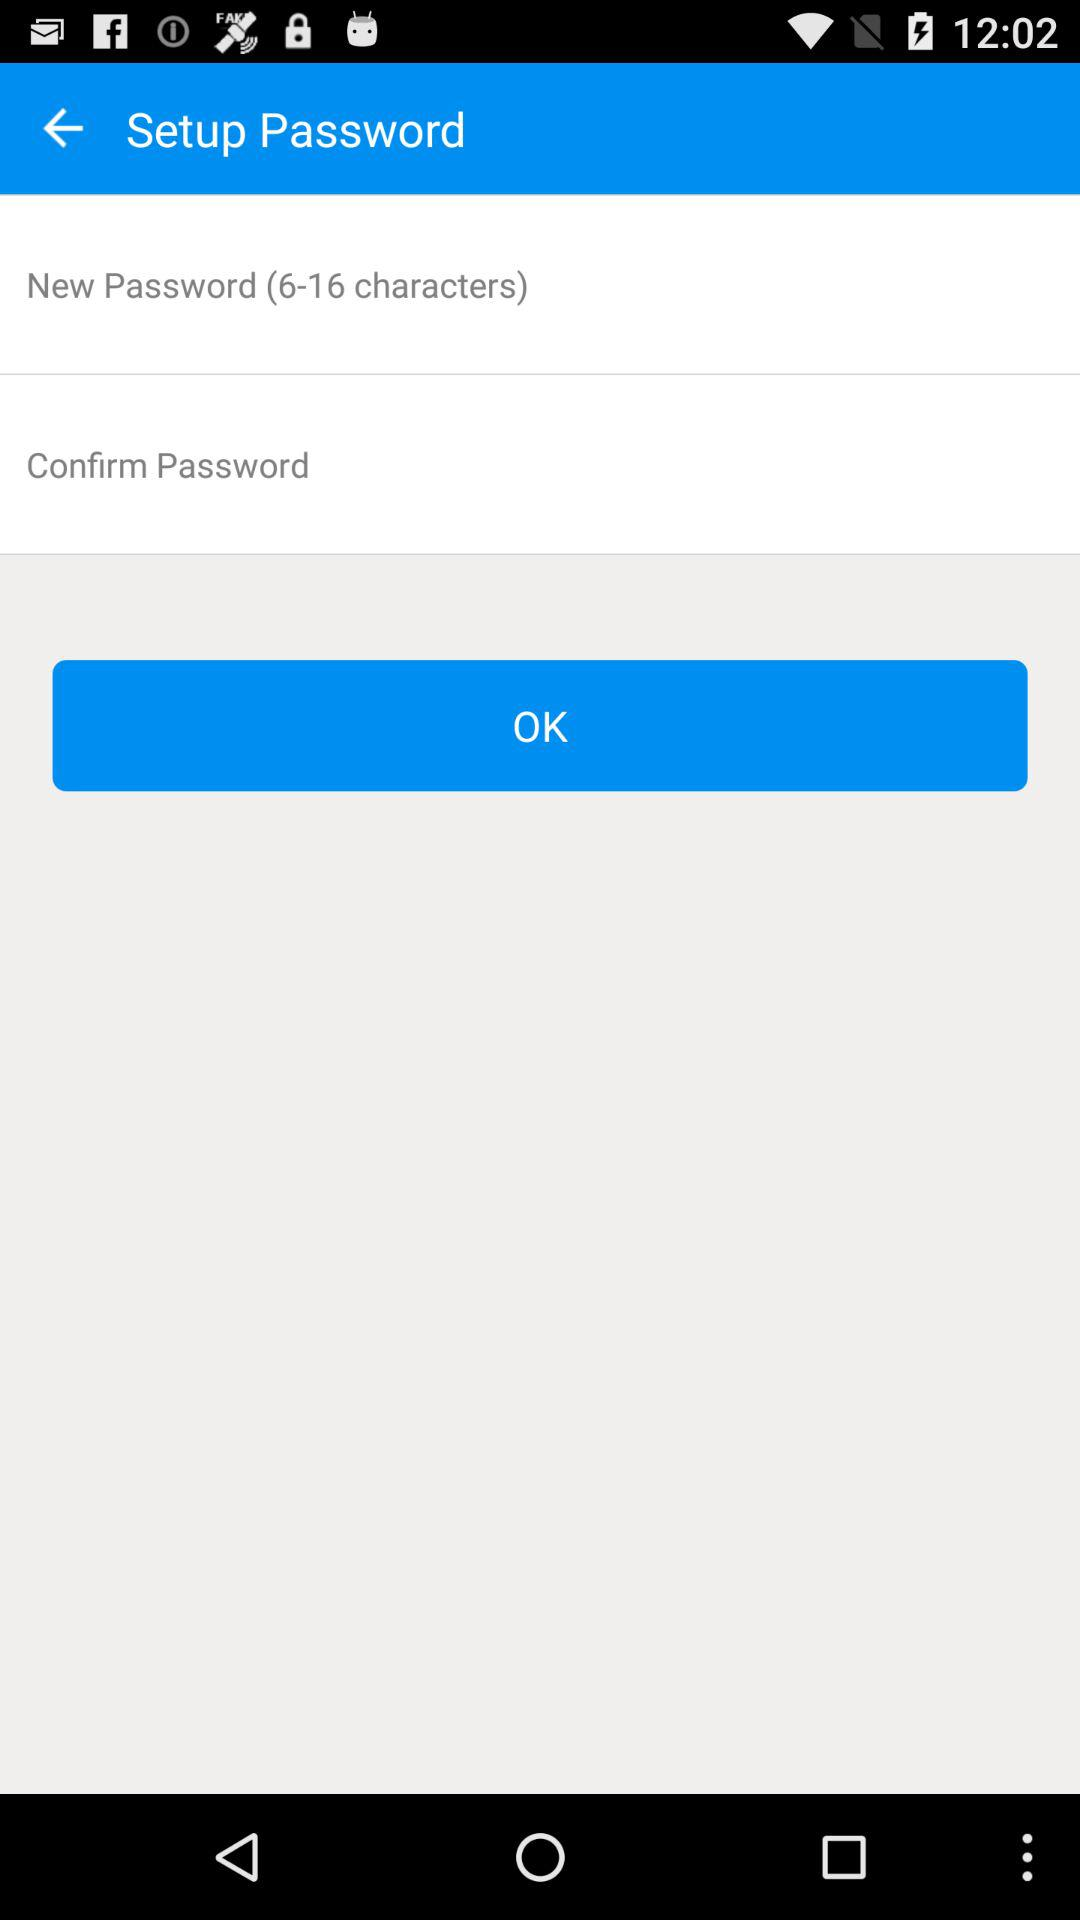What is the range of characters for the new password? The range is 6 to 16 characters. 